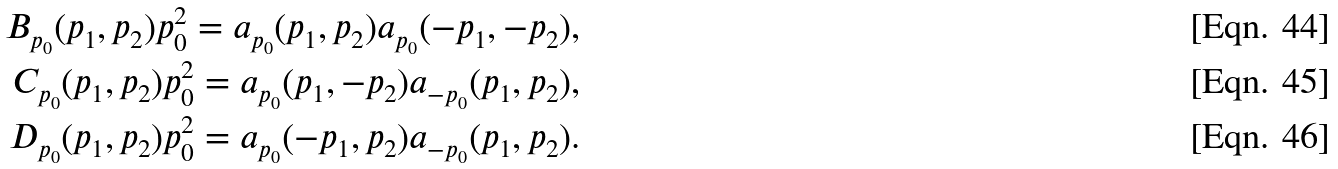<formula> <loc_0><loc_0><loc_500><loc_500>B _ { p _ { 0 } } ( p _ { 1 } , p _ { 2 } ) p _ { 0 } ^ { 2 } = a _ { p _ { 0 } } ( p _ { 1 } , p _ { 2 } ) a _ { p _ { 0 } } ( - p _ { 1 } , - p _ { 2 } ) , \\ C _ { p _ { 0 } } ( p _ { 1 } , p _ { 2 } ) p _ { 0 } ^ { 2 } = a _ { p _ { 0 } } ( p _ { 1 } , - p _ { 2 } ) a _ { - p _ { 0 } } ( p _ { 1 } , p _ { 2 } ) , \\ D _ { p _ { 0 } } ( p _ { 1 } , p _ { 2 } ) p _ { 0 } ^ { 2 } = a _ { p _ { 0 } } ( - p _ { 1 } , p _ { 2 } ) a _ { - p _ { 0 } } ( p _ { 1 } , p _ { 2 } ) .</formula> 